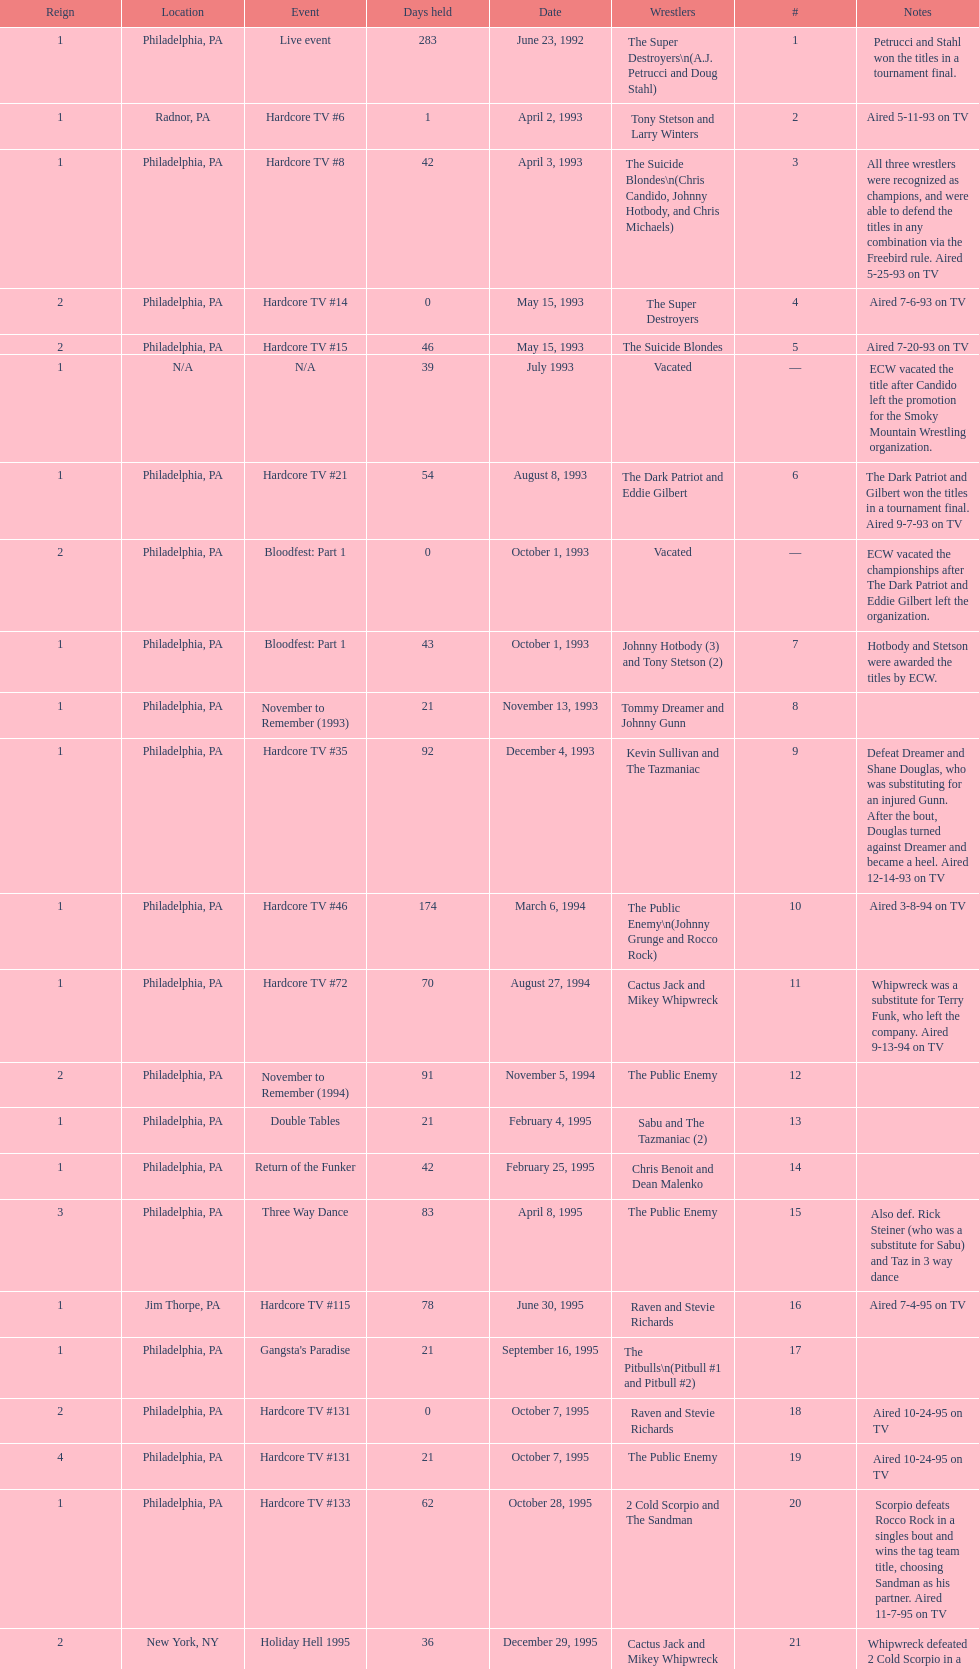Which was the only team to win by forfeit? The Dudley Boyz. 